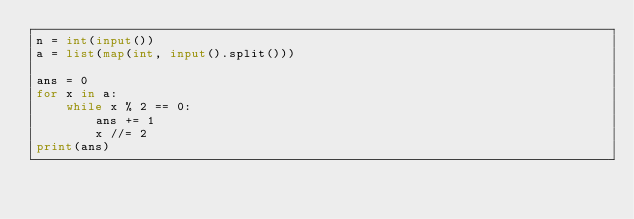Convert code to text. <code><loc_0><loc_0><loc_500><loc_500><_Python_>n = int(input())
a = list(map(int, input().split()))

ans = 0
for x in a:
    while x % 2 == 0:
        ans += 1
        x //= 2
print(ans)
</code> 